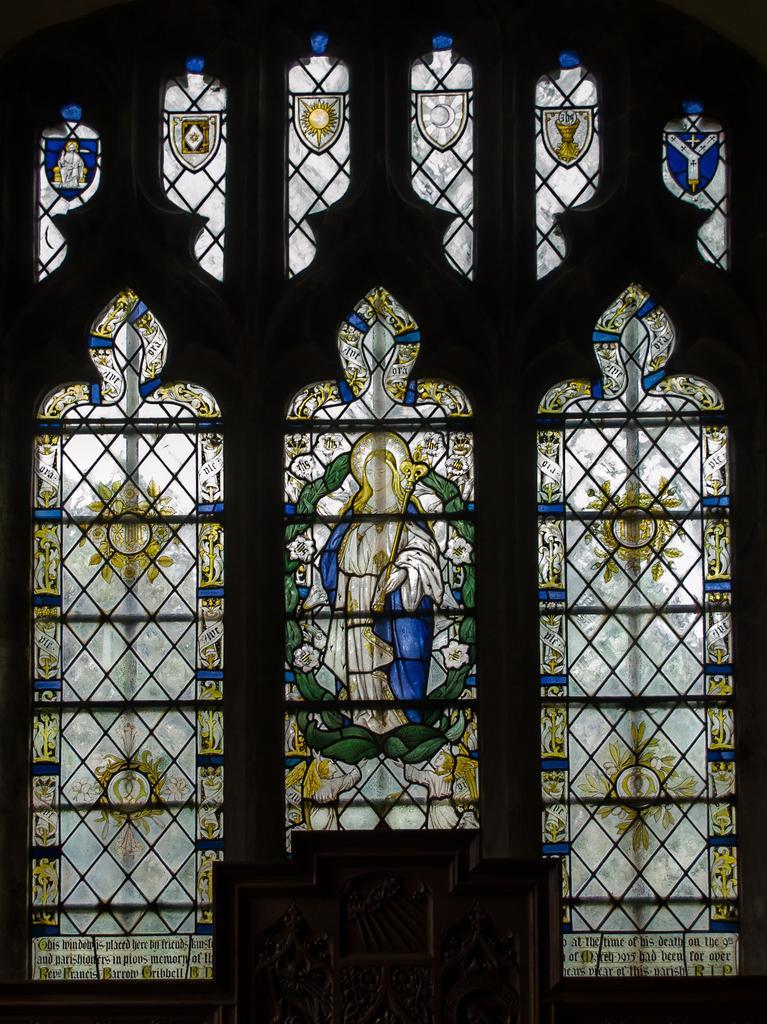In one or two sentences, can you explain what this image depicts? In this image there is a window and on the window there is some art, at the bottom there are some objects. 